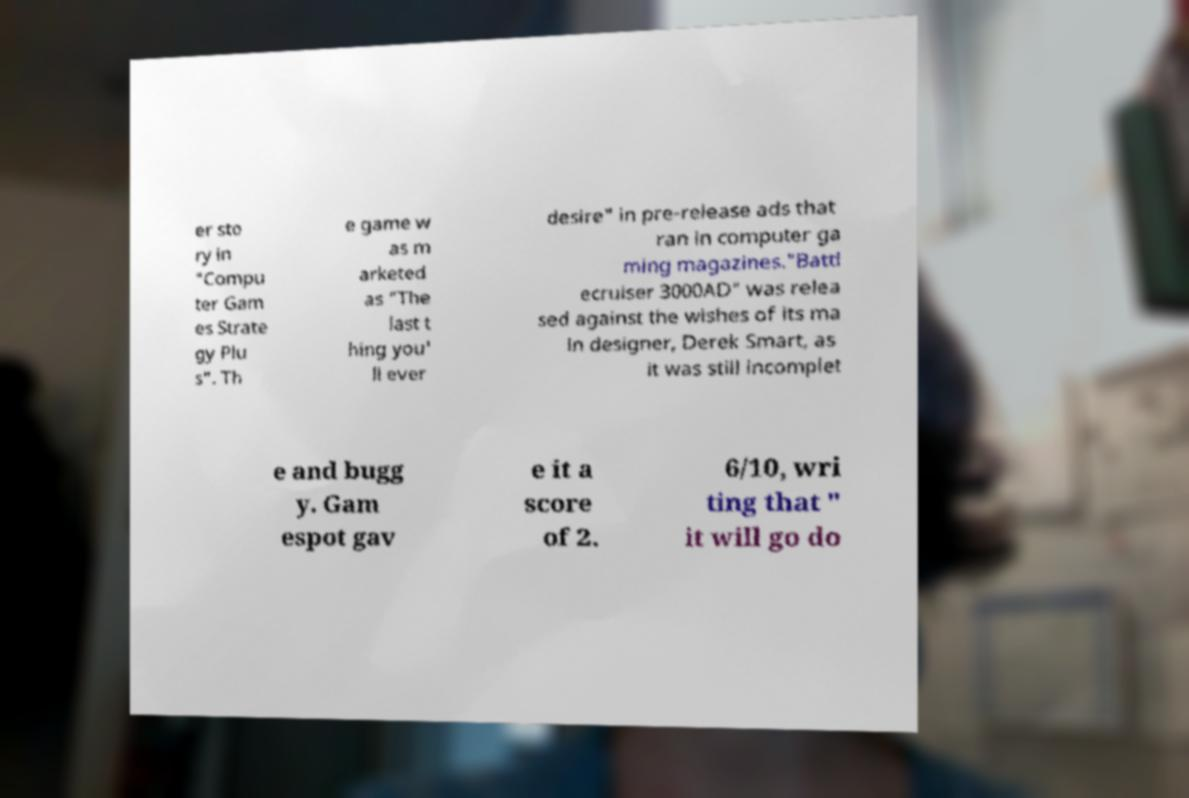There's text embedded in this image that I need extracted. Can you transcribe it verbatim? er sto ry in "Compu ter Gam es Strate gy Plu s". Th e game w as m arketed as "The last t hing you' ll ever desire" in pre-release ads that ran in computer ga ming magazines."Battl ecruiser 3000AD" was relea sed against the wishes of its ma in designer, Derek Smart, as it was still incomplet e and bugg y. Gam espot gav e it a score of 2. 6/10, wri ting that " it will go do 